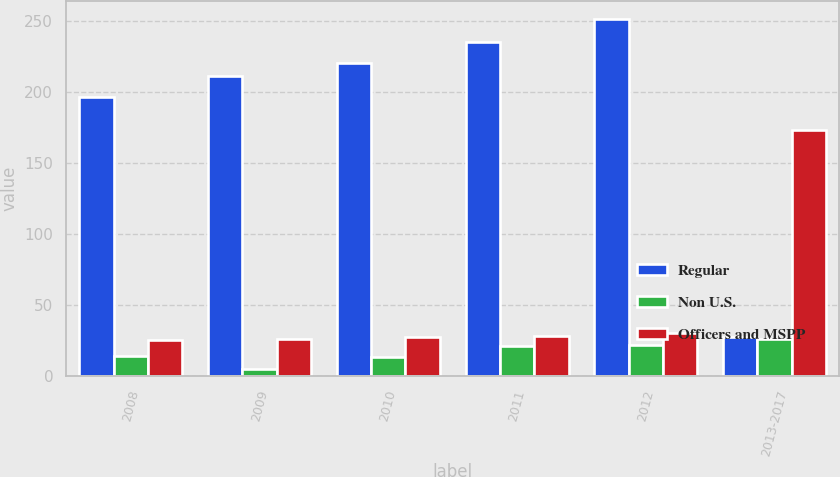<chart> <loc_0><loc_0><loc_500><loc_500><stacked_bar_chart><ecel><fcel>2008<fcel>2009<fcel>2010<fcel>2011<fcel>2012<fcel>2013-2017<nl><fcel>Regular<fcel>196<fcel>211<fcel>220<fcel>235<fcel>251<fcel>27<nl><fcel>Non U.S.<fcel>14<fcel>5<fcel>13<fcel>21<fcel>22<fcel>26<nl><fcel>Officers and MSPP<fcel>25<fcel>26<fcel>27<fcel>28<fcel>30<fcel>173<nl></chart> 